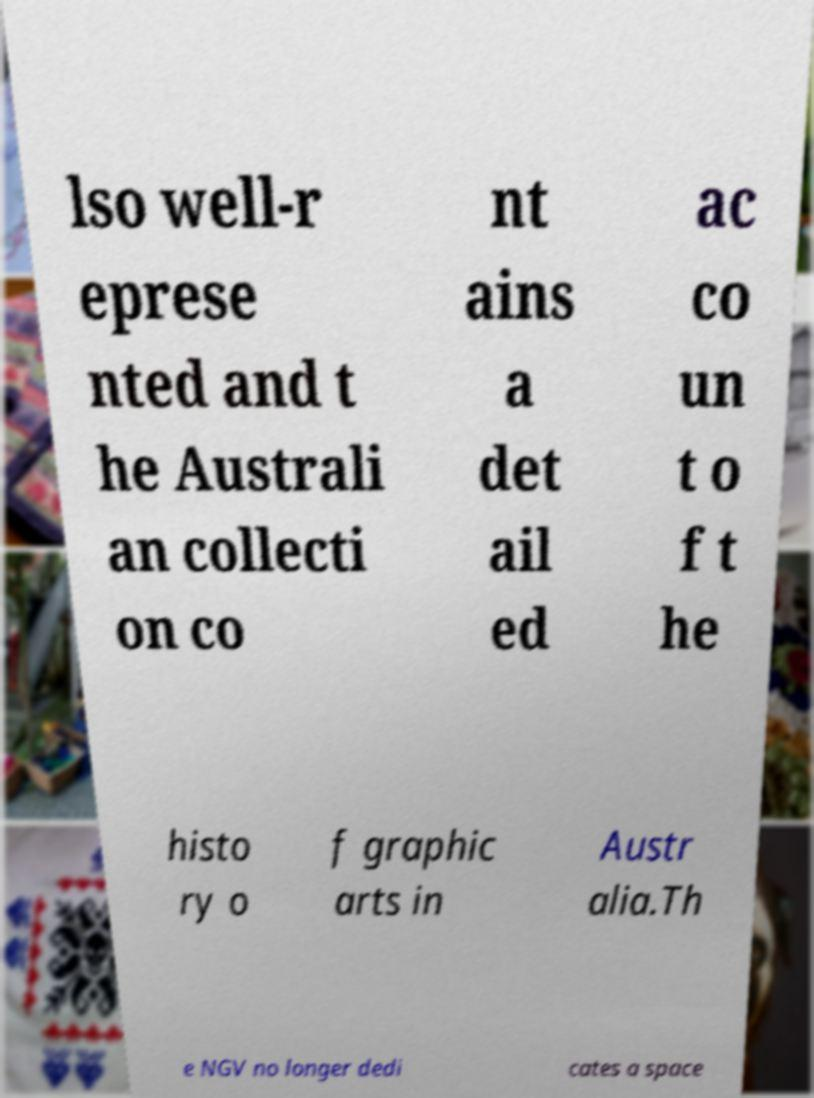Please read and relay the text visible in this image. What does it say? lso well-r eprese nted and t he Australi an collecti on co nt ains a det ail ed ac co un t o f t he histo ry o f graphic arts in Austr alia.Th e NGV no longer dedi cates a space 